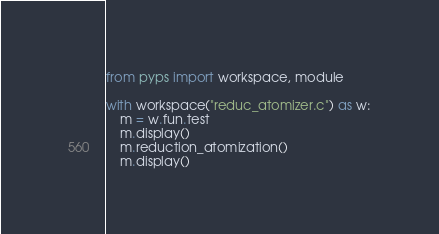<code> <loc_0><loc_0><loc_500><loc_500><_Python_>from pyps import workspace, module

with workspace("reduc_atomizer.c") as w:
	m = w.fun.test
	m.display()
	m.reduction_atomization()
	m.display()
</code> 